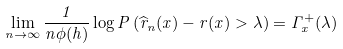Convert formula to latex. <formula><loc_0><loc_0><loc_500><loc_500>\lim _ { n \rightarrow \infty } \frac { 1 } { n \phi ( h ) } \log P \left ( \widehat { r } _ { n } ( x ) - r ( x ) > \lambda \right ) = \Gamma _ { x } ^ { + } ( \lambda )</formula> 